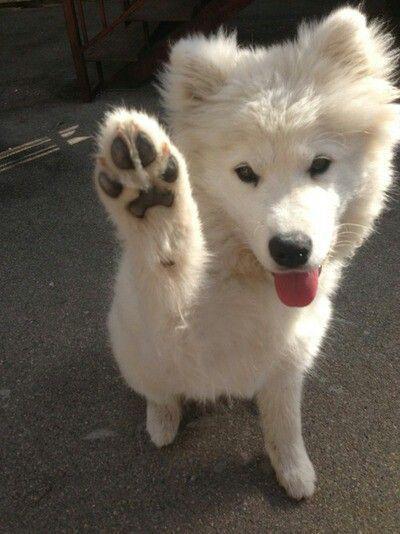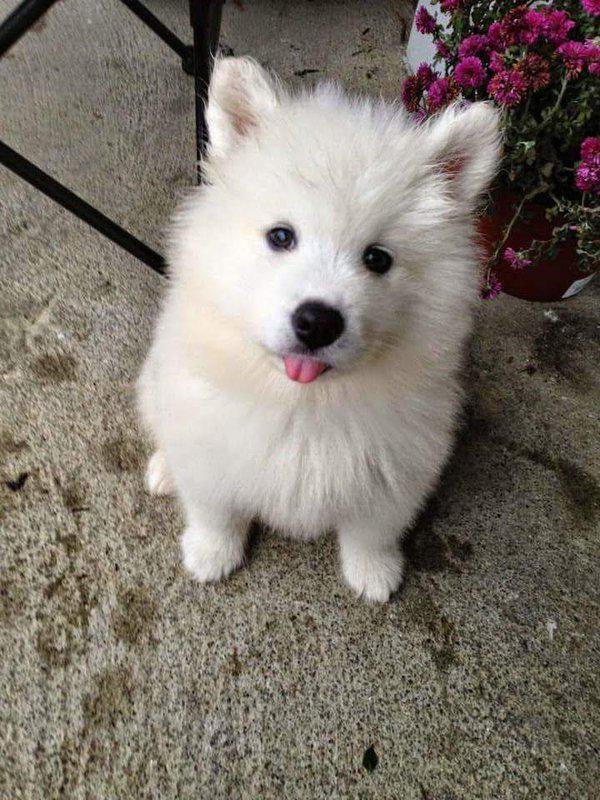The first image is the image on the left, the second image is the image on the right. For the images displayed, is the sentence "An image includes a reclining white dog with both eyes shut." factually correct? Answer yes or no. No. The first image is the image on the left, the second image is the image on the right. Examine the images to the left and right. Is the description "The dog's tongue is sticking out in at least one of the images." accurate? Answer yes or no. Yes. 